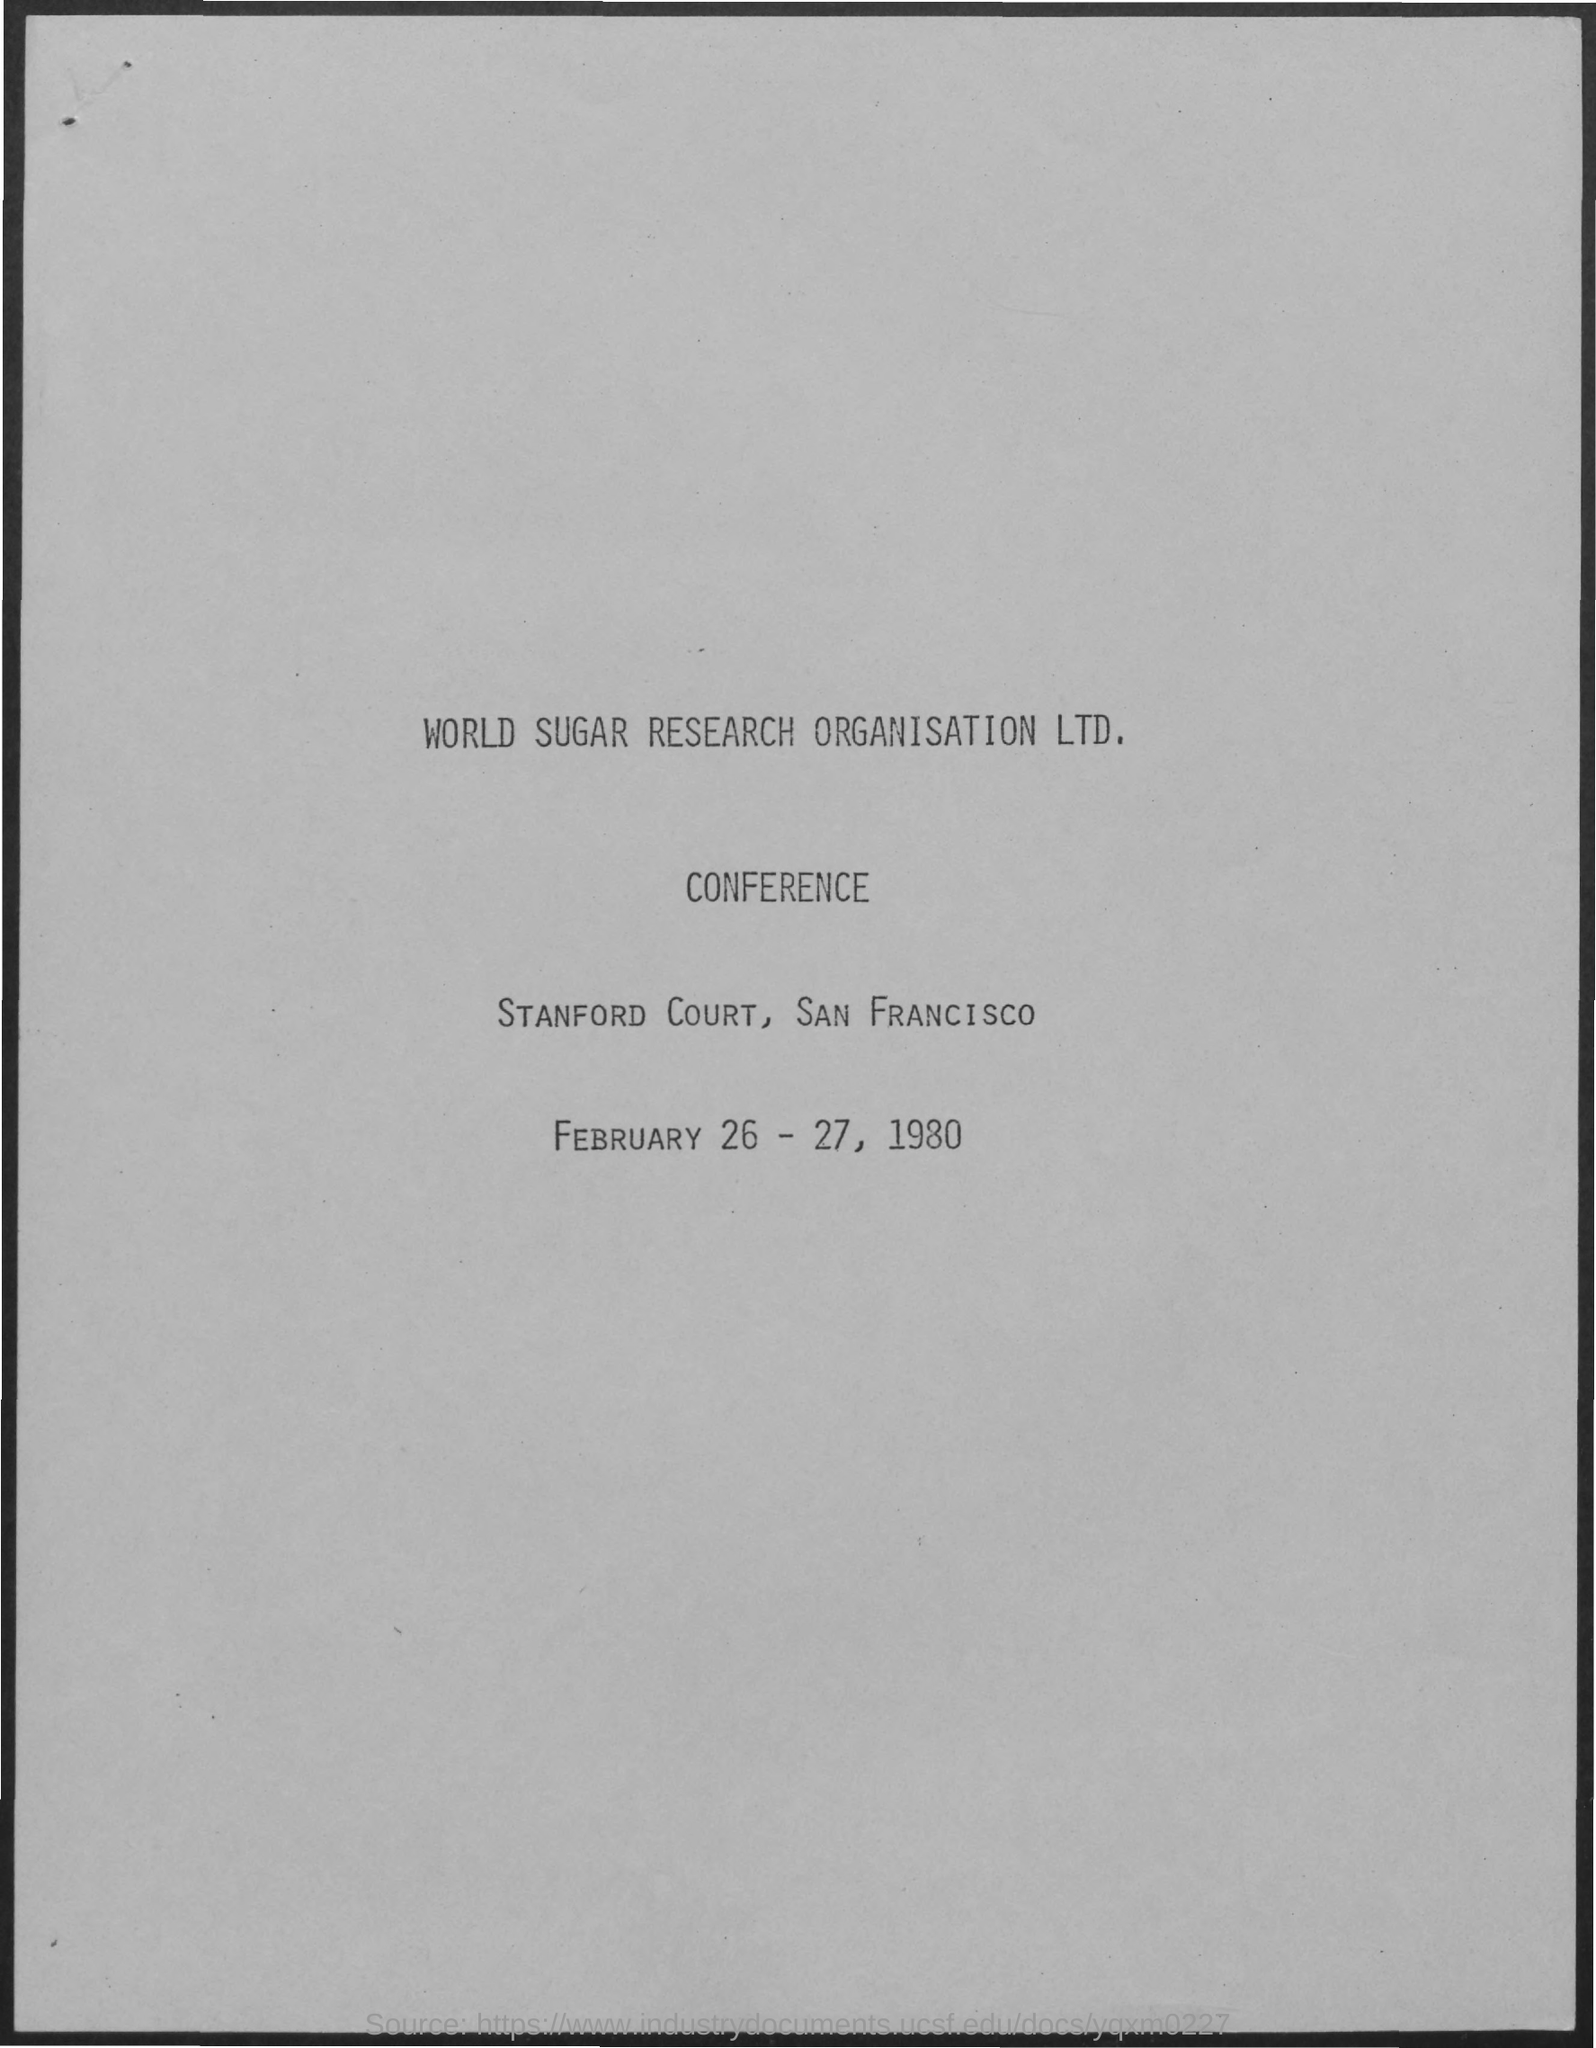When is the Conference of World Sugar Research Organisation Ltd. held?
Offer a very short reply. FEBRUARY 26-27, 1980. Where is the Conference of World Sugar Research Organisation Ltd. organized?
Your response must be concise. STANFORD COURT, SAN FRANCISCO. 